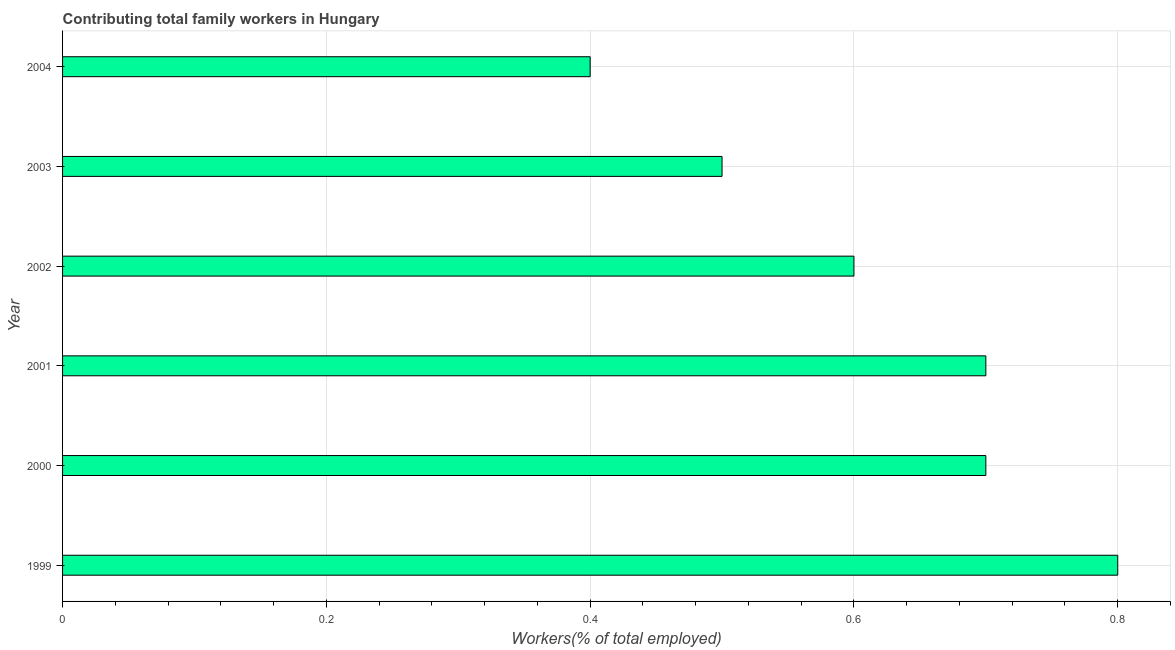What is the title of the graph?
Provide a short and direct response. Contributing total family workers in Hungary. What is the label or title of the X-axis?
Your answer should be compact. Workers(% of total employed). What is the contributing family workers in 2004?
Provide a short and direct response. 0.4. Across all years, what is the maximum contributing family workers?
Your response must be concise. 0.8. Across all years, what is the minimum contributing family workers?
Your answer should be compact. 0.4. What is the sum of the contributing family workers?
Your answer should be compact. 3.7. What is the average contributing family workers per year?
Your answer should be compact. 0.62. What is the median contributing family workers?
Keep it short and to the point. 0.65. What is the ratio of the contributing family workers in 1999 to that in 2004?
Make the answer very short. 2. Is the contributing family workers in 1999 less than that in 2003?
Keep it short and to the point. No. What is the difference between the highest and the second highest contributing family workers?
Keep it short and to the point. 0.1. How many bars are there?
Provide a short and direct response. 6. What is the Workers(% of total employed) in 1999?
Offer a terse response. 0.8. What is the Workers(% of total employed) of 2000?
Your answer should be compact. 0.7. What is the Workers(% of total employed) of 2001?
Your answer should be very brief. 0.7. What is the Workers(% of total employed) of 2002?
Give a very brief answer. 0.6. What is the Workers(% of total employed) in 2003?
Offer a terse response. 0.5. What is the Workers(% of total employed) of 2004?
Give a very brief answer. 0.4. What is the difference between the Workers(% of total employed) in 1999 and 2000?
Provide a short and direct response. 0.1. What is the difference between the Workers(% of total employed) in 1999 and 2003?
Your answer should be very brief. 0.3. What is the difference between the Workers(% of total employed) in 1999 and 2004?
Provide a succinct answer. 0.4. What is the difference between the Workers(% of total employed) in 2000 and 2002?
Your answer should be very brief. 0.1. What is the difference between the Workers(% of total employed) in 2000 and 2003?
Your answer should be compact. 0.2. What is the difference between the Workers(% of total employed) in 2001 and 2002?
Your answer should be very brief. 0.1. What is the difference between the Workers(% of total employed) in 2001 and 2003?
Ensure brevity in your answer.  0.2. What is the difference between the Workers(% of total employed) in 2002 and 2004?
Give a very brief answer. 0.2. What is the difference between the Workers(% of total employed) in 2003 and 2004?
Your response must be concise. 0.1. What is the ratio of the Workers(% of total employed) in 1999 to that in 2000?
Provide a short and direct response. 1.14. What is the ratio of the Workers(% of total employed) in 1999 to that in 2001?
Your answer should be very brief. 1.14. What is the ratio of the Workers(% of total employed) in 1999 to that in 2002?
Your answer should be very brief. 1.33. What is the ratio of the Workers(% of total employed) in 1999 to that in 2004?
Provide a succinct answer. 2. What is the ratio of the Workers(% of total employed) in 2000 to that in 2002?
Give a very brief answer. 1.17. What is the ratio of the Workers(% of total employed) in 2001 to that in 2002?
Provide a short and direct response. 1.17. What is the ratio of the Workers(% of total employed) in 2001 to that in 2004?
Your answer should be compact. 1.75. What is the ratio of the Workers(% of total employed) in 2002 to that in 2004?
Give a very brief answer. 1.5. 